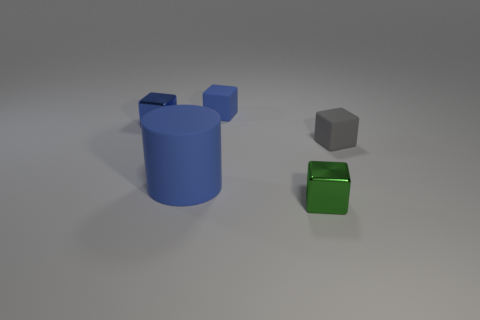Which object stands out the most and why? The green cube stands out due to its vibrant color and reflective surface, contrasted against the more subdued matte textures of the blue cylinder and gray cube. 